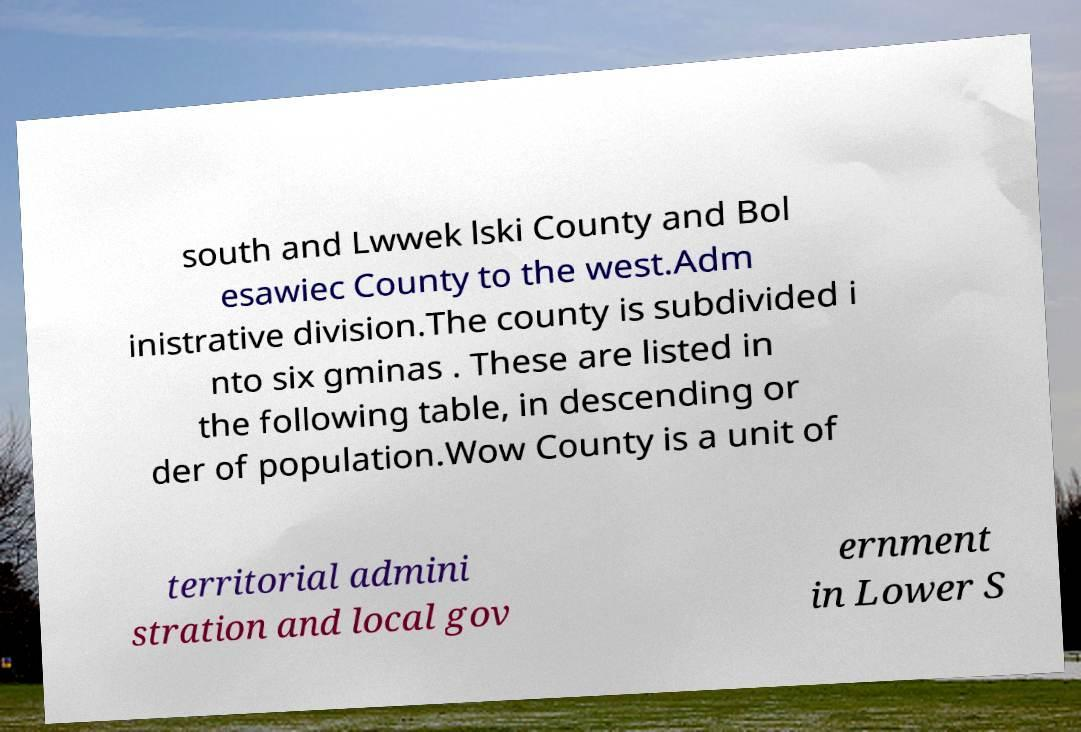There's text embedded in this image that I need extracted. Can you transcribe it verbatim? south and Lwwek lski County and Bol esawiec County to the west.Adm inistrative division.The county is subdivided i nto six gminas . These are listed in the following table, in descending or der of population.Wow County is a unit of territorial admini stration and local gov ernment in Lower S 